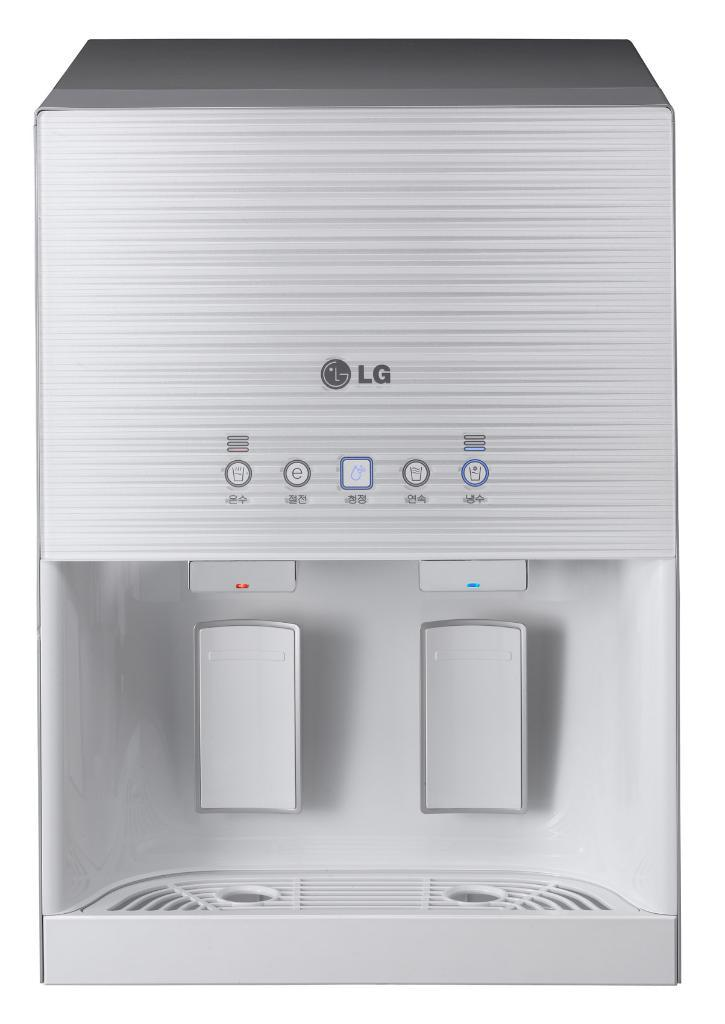What is the main object in the image? There is a water purifier in the image. What features can be seen on the water purifier? The water purifier has buttons and text on it. What is the color of the background in the image? The background of the image is white in color. How many passengers are visible in the image? There are no passengers present in the image; it features a water purifier with buttons and text on a white background. 